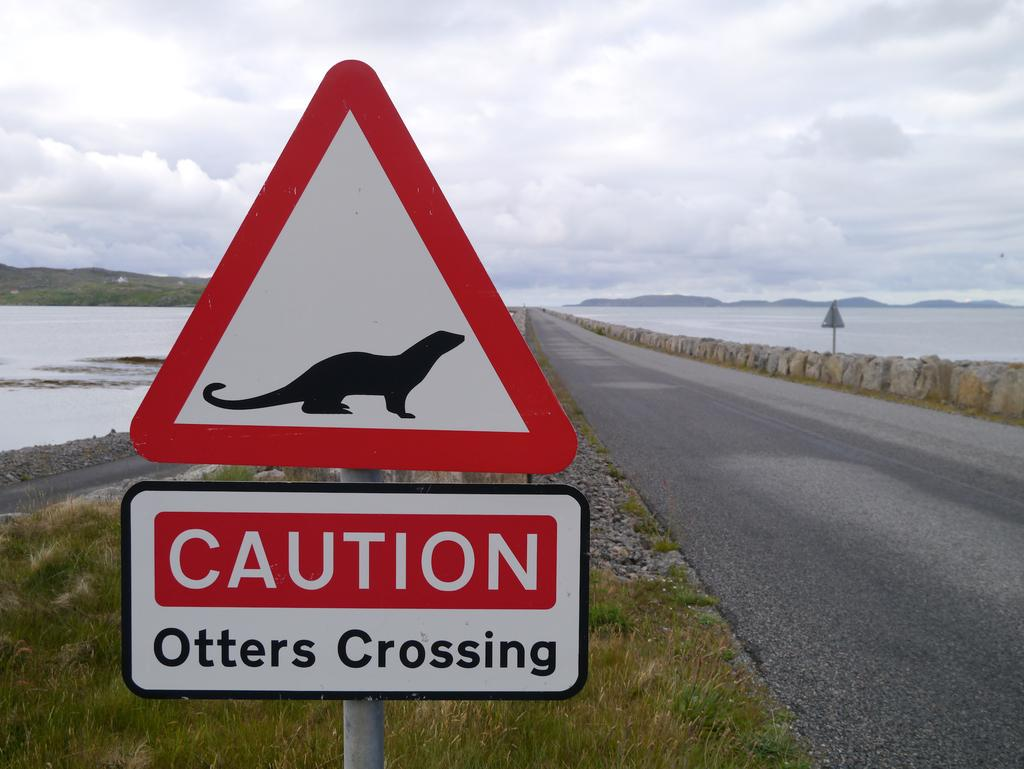Provide a one-sentence caption for the provided image. A white sign with a black profile of an otter with red boarders near a road warning of otters crossing. 